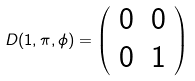Convert formula to latex. <formula><loc_0><loc_0><loc_500><loc_500>D ( 1 , \pi , \phi ) = \left ( \begin{array} { c c } 0 & 0 \\ 0 & 1 \end{array} \right )</formula> 